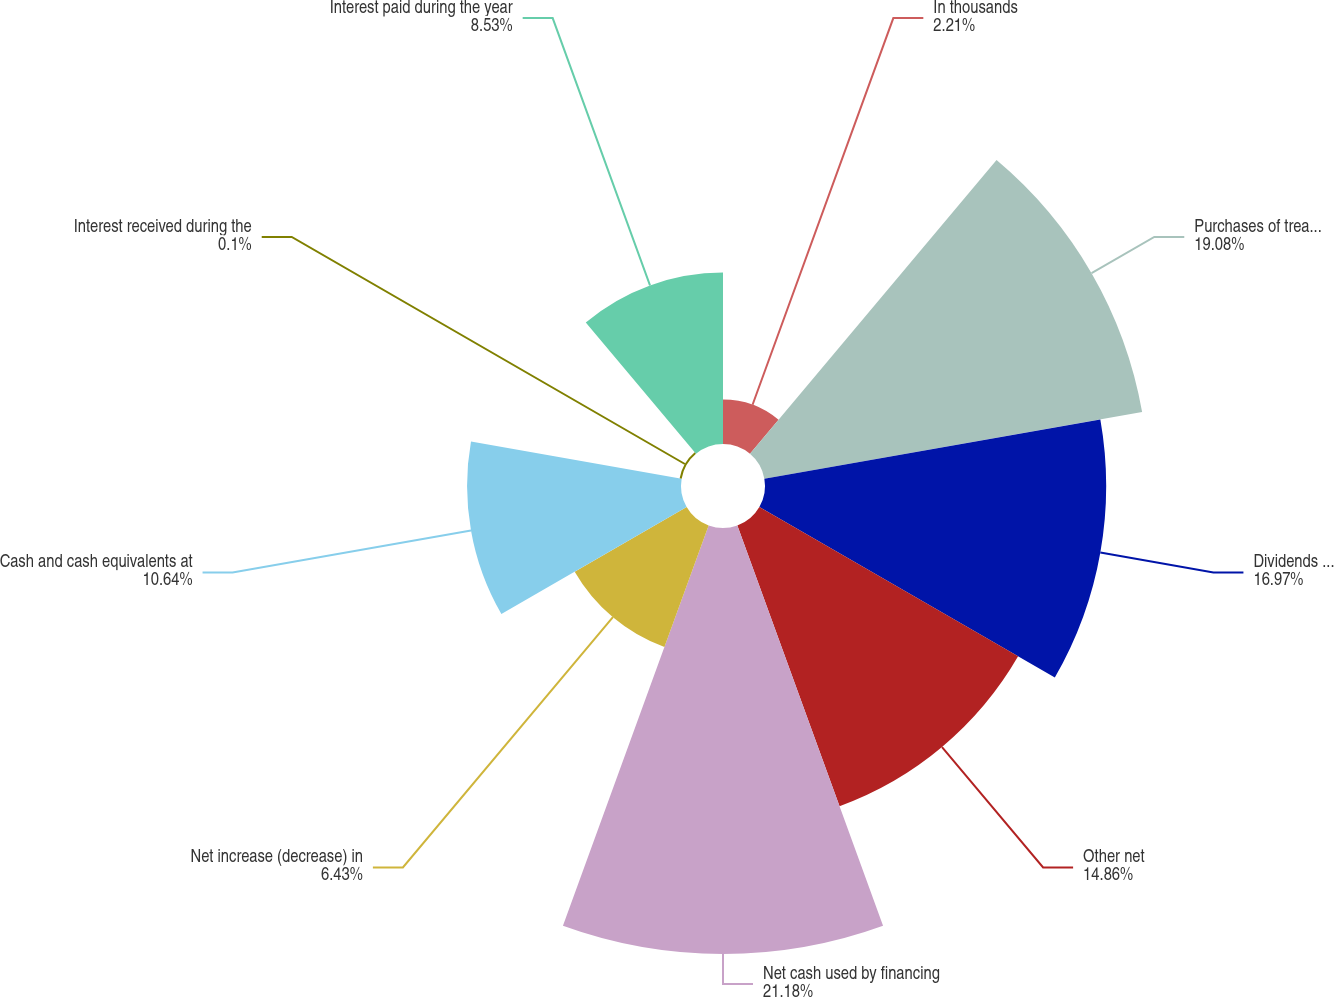<chart> <loc_0><loc_0><loc_500><loc_500><pie_chart><fcel>In thousands<fcel>Purchases of treasury stock<fcel>Dividends paid - common<fcel>Other net<fcel>Net cash used by financing<fcel>Net increase (decrease) in<fcel>Cash and cash equivalents at<fcel>Interest received during the<fcel>Interest paid during the year<nl><fcel>2.21%<fcel>19.08%<fcel>16.97%<fcel>14.86%<fcel>21.19%<fcel>6.43%<fcel>10.64%<fcel>0.1%<fcel>8.53%<nl></chart> 